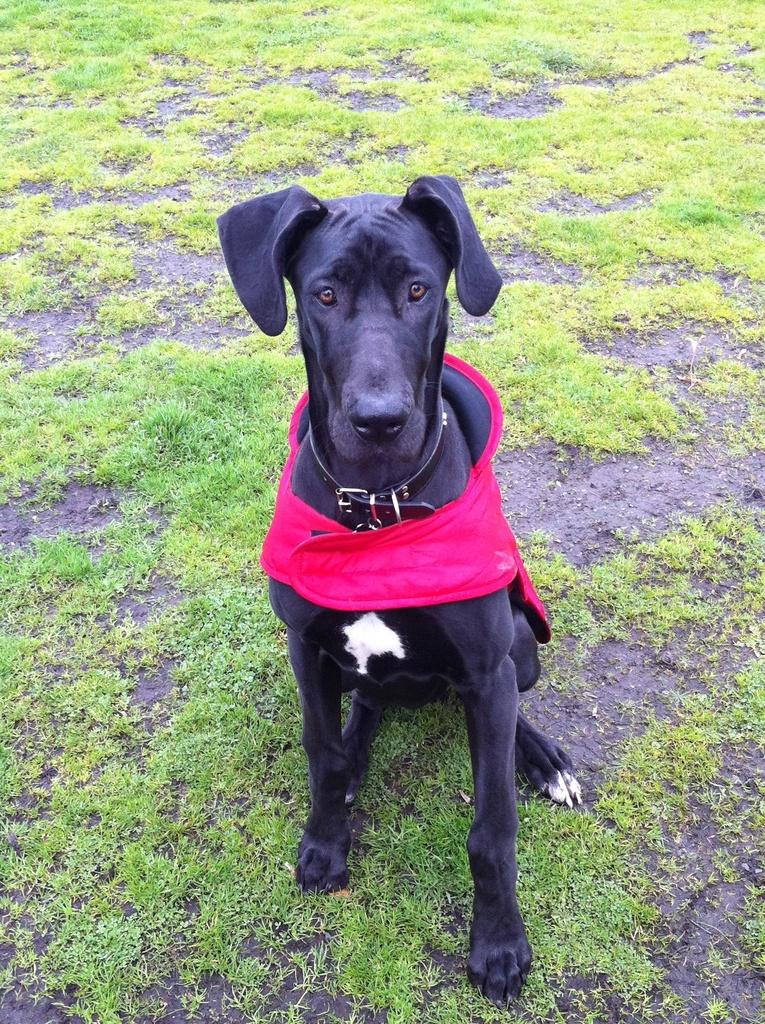What type of animal is present in the image? There is a dog in the image. Where is the dog located? The dog is sitting on the land. What is the condition of the land? The land has some grass. What is the dog wearing? The dog is wearing a cloth. How does the manager feel about the dog smashing the glass in the image? There is no manager or glass present in the image, so it is not possible to determine how a manager might feel about the dog smashing glass. 